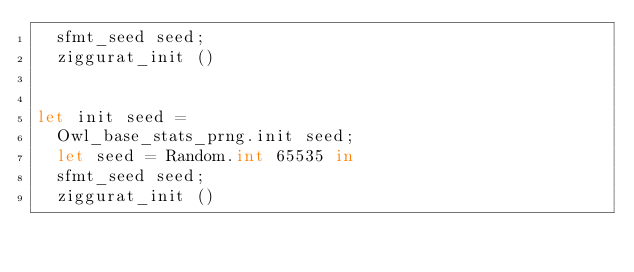Convert code to text. <code><loc_0><loc_0><loc_500><loc_500><_OCaml_>  sfmt_seed seed;
  ziggurat_init ()


let init seed =
  Owl_base_stats_prng.init seed;
  let seed = Random.int 65535 in
  sfmt_seed seed;
  ziggurat_init ()
</code> 